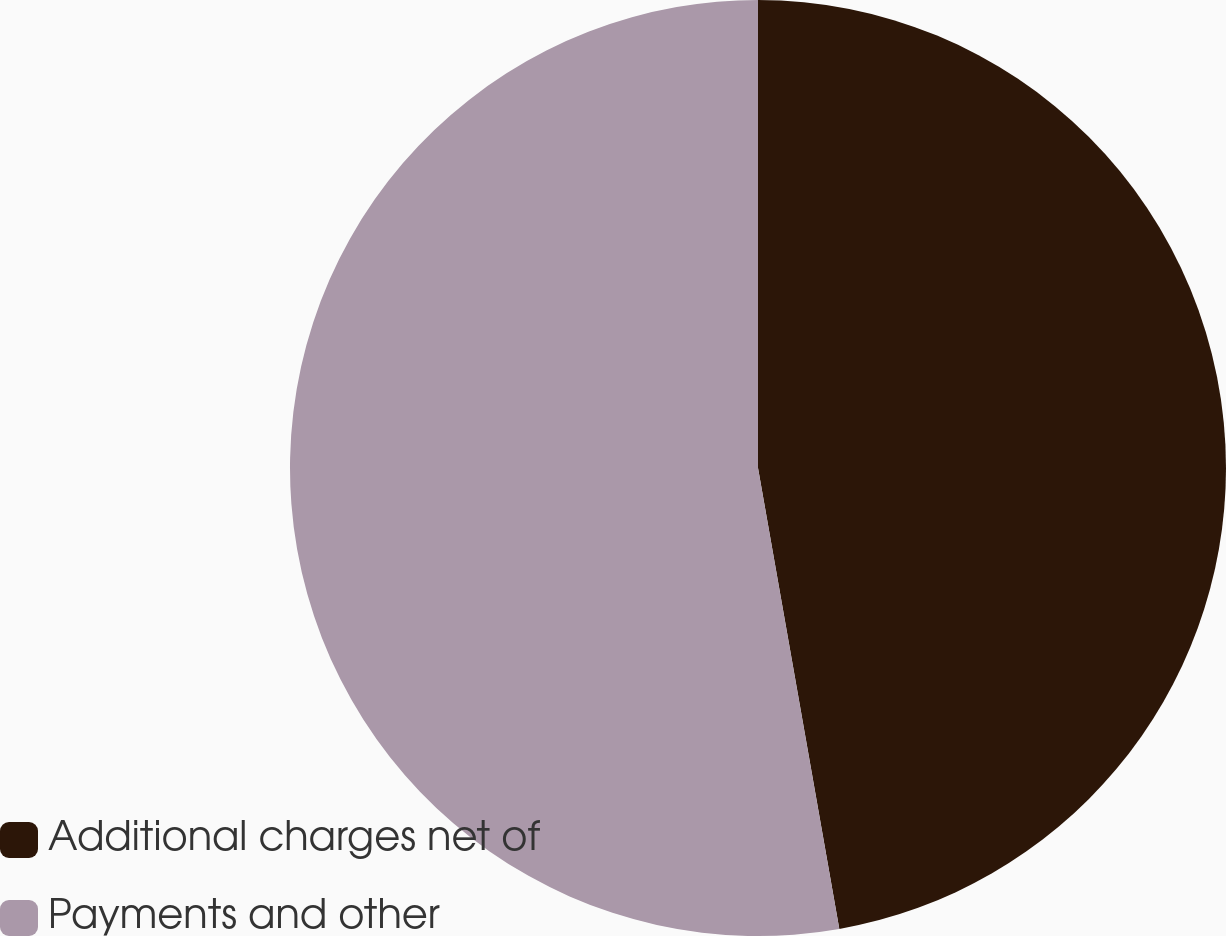Convert chart to OTSL. <chart><loc_0><loc_0><loc_500><loc_500><pie_chart><fcel>Additional charges net of<fcel>Payments and other<nl><fcel>47.22%<fcel>52.78%<nl></chart> 